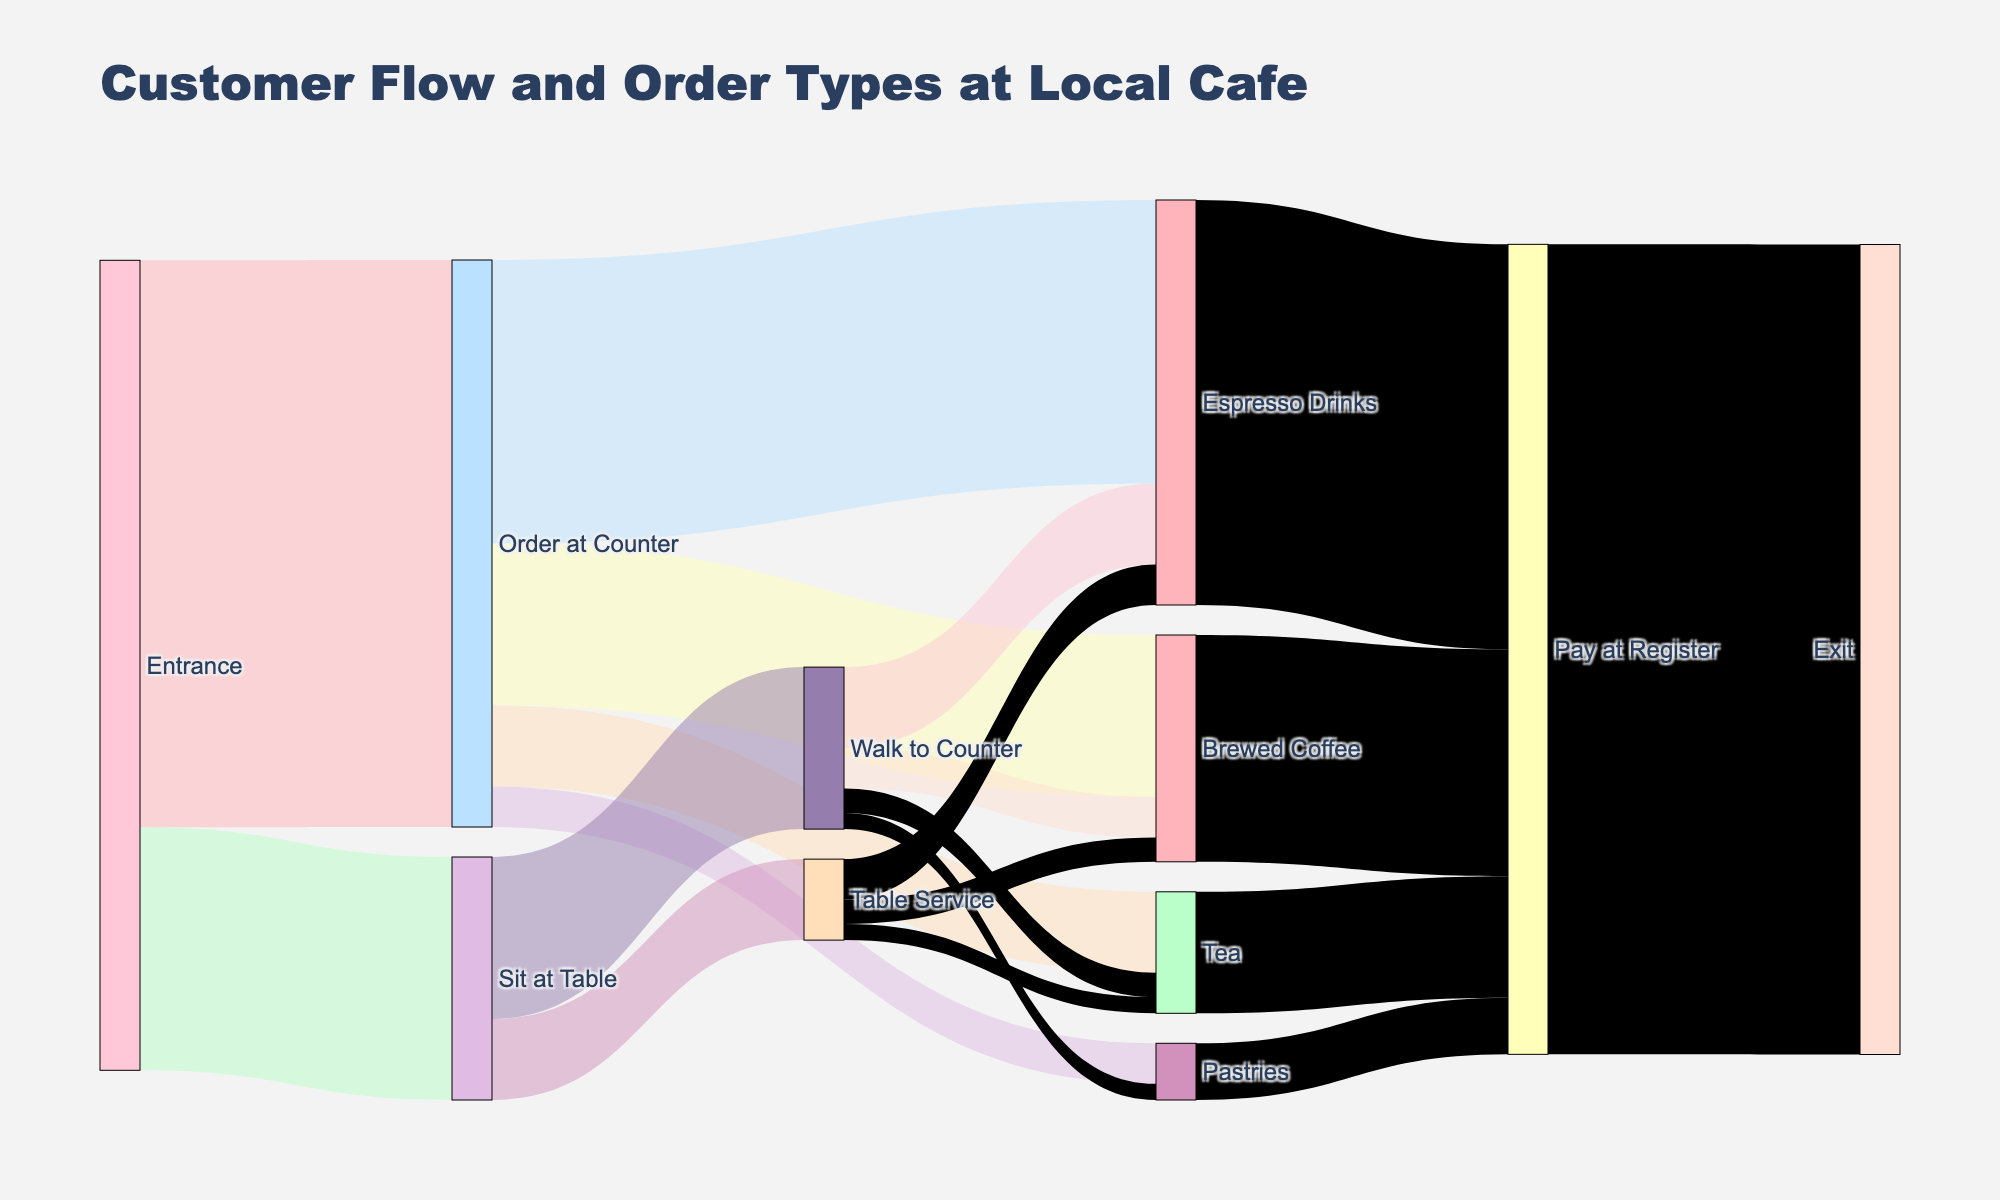What is the title of the figure? The title of the figure is usually located at the top of the plot and provides an overview of what the diagram represents. In this case, we're told that the plot showcases customer flow and order types at a local cafe.
Answer: Customer Flow and Order Types at Local Cafe How many customers order at the counter? To find this, look for the flow from "Entrance" to "Order at Counter". The diagram says 70 customers enter and order at the counter.
Answer: 70 How many customers opt for table service after sitting at a table? Look for the connection from "Sit at Table" to "Table Service". According to the figure, 10 customers choose table service.
Answer: 10 Compare the number of customers who order brewed coffee with table service versus those who order brewed coffee at the counter. How many more or less choose table service? Find the flows "Table Service" to "Brewed Coffee" and "Order at Counter" to "Brewed Coffee". 3 customers choose table service and 20 choose the counter. Hence, 20 - 3 = 17 more customers choose brewed coffee at the counter.
Answer: 17 more Which order type has the highest count of customers? Check the order types and their values after "Order at Counter", "Walk to Counter", and "Table Service". "Espresso Drinks" has the highest value with 35 (from counter) + 10 (walk to counter) + 5 (table service) = 50.
Answer: Espresso Drinks What is the total number of customers that pay at the register? Look for the combined flow values that lead to "Pay at Register". This includes flows from "Espresso Drinks", "Brewed Coffee", "Tea", and "Pastries". These values are 50, 28, 15, and 7 respectively. Summing these: 50 + 28 + 15 + 7 = 100.
Answer: 100 What percentage of customers choose to sit at the table initially? Check the flow from "Entrance" to "Sit at Table" and then divide it by the total number of entries. 30 customers sit at the table out of 100 total customers (70 at counter + 30 at table). Thus, (30/100) * 100% = 30%.
Answer: 30% What’s the sum of customers who order tea from all available routes? Tea orders can come from "Order at Counter", "Walk to Counter", and "Table Service". The values are 10 (at counter), 3 (walk), and 2 (table). Summing these: 10 + 3 + 2 = 15.
Answer: 15 What is the difference between customers who order pastries at the counter and those who walk to the counter for pastries? The number of customers for each route is 5 (at counter) and 2 (walk to counter). The difference is 5 - 2 = 3.
Answer: 3 How many customers choose to exit after paying at the register? According to the flow, everyone who pays at the register (100 customers) exits. Therefore, 100 customers exit.
Answer: 100 